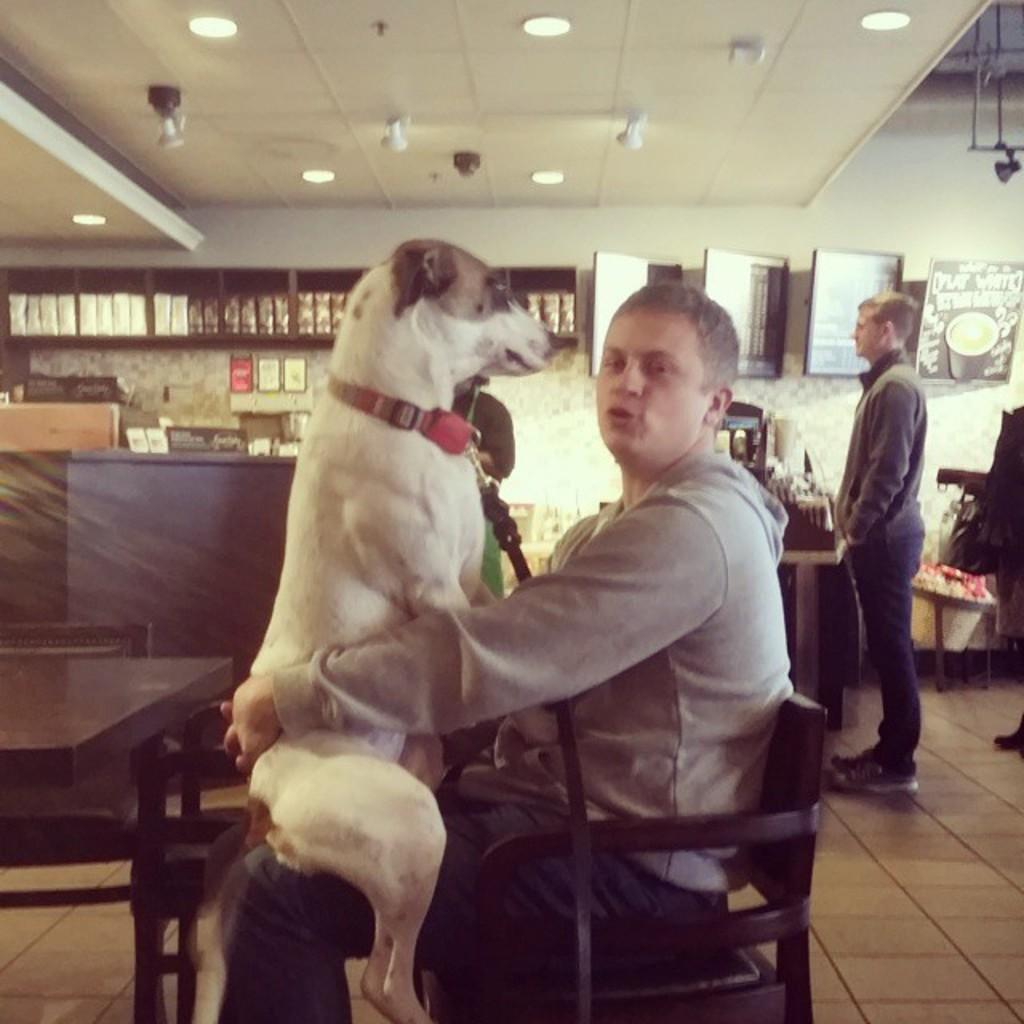What is the man in the image doing? There is a man sitting on a chair in the image, and he is holding a dog in his lap. Can you describe the position of the second man in the image? The second man is standing in front of a table in the image. What type of grass is growing in the man's stomach in the image? There is no grass or reference to a stomach in the image; it only features two men, one sitting and holding a dog, and the other standing in front of a table. 